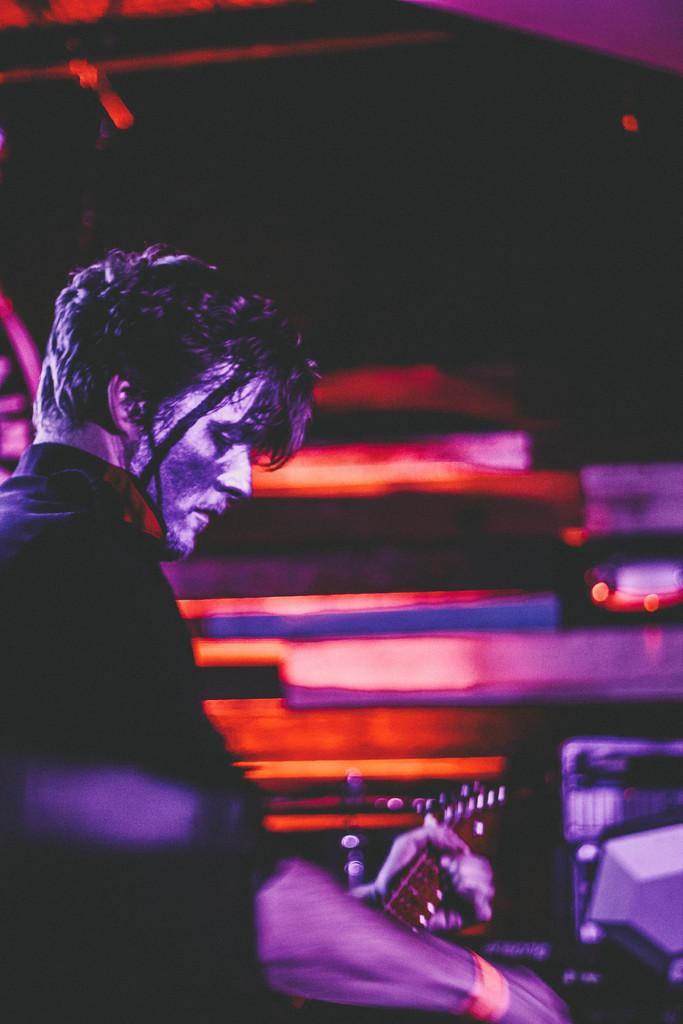Could you give a brief overview of what you see in this image? In this image we can see a person playing a musical instrument. There are few wooden objects in the image. There is a musical instrument at the right side of the image. There is a dark background at the top of the image. 